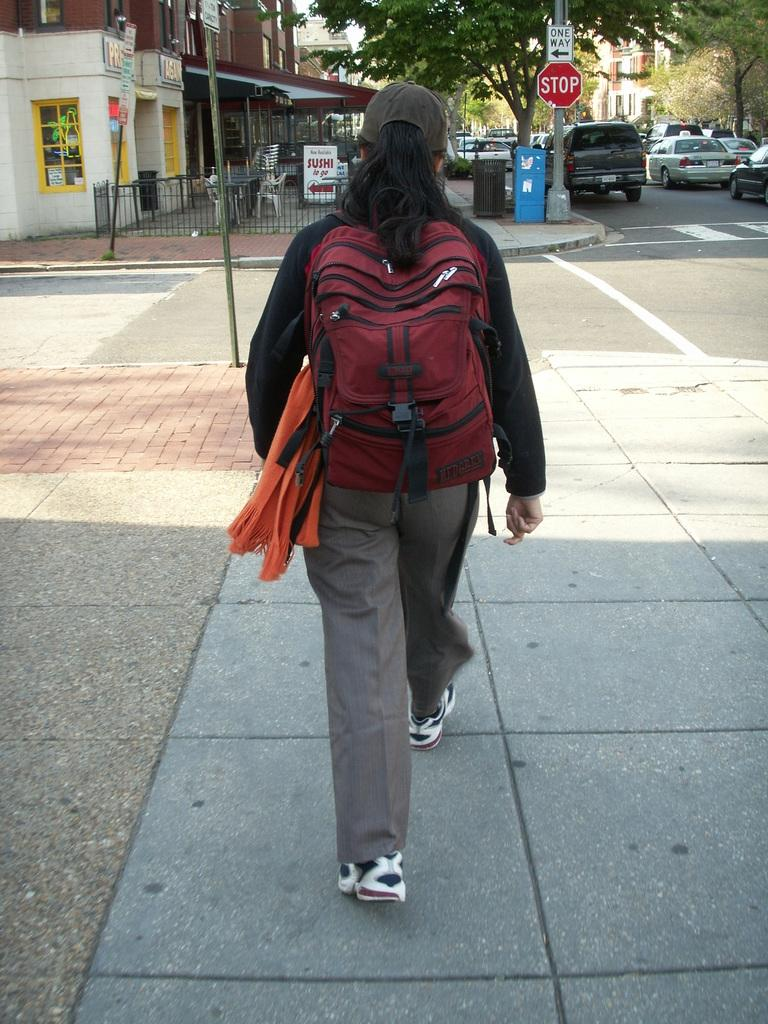Who is the main subject in the image? There is a woman in the image. What is the woman doing in the image? The woman is walking on a sidewalk. What accessories is the woman wearing in the image? The woman is wearing a bag, a cap, and shoes. What can be seen in the background of the image? There is a building, a fence, a pole, a signboard, a dustbin, vehicles, and trees in the background of the image. How many snails are crawling on the woman's bag in the image? There are no snails visible in the image. What type of bun is the woman holding in the image? There is no bun present in the image. What is the woman's name in the image? The image does not provide any information about the woman's name. 